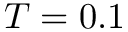<formula> <loc_0><loc_0><loc_500><loc_500>T = 0 . 1</formula> 